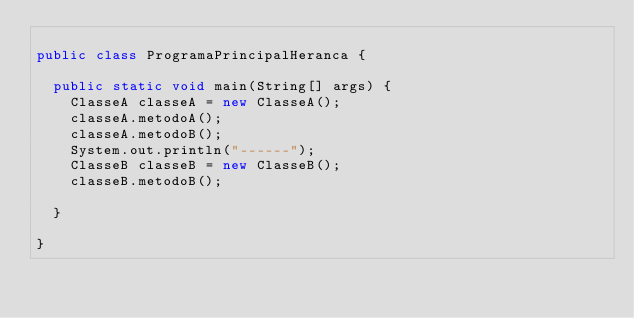<code> <loc_0><loc_0><loc_500><loc_500><_Java_>
public class ProgramaPrincipalHeranca {

	public static void main(String[] args) {
		ClasseA classeA = new ClasseA();
		classeA.metodoA();
		classeA.metodoB();
		System.out.println("------");
		ClasseB classeB = new ClasseB();
		classeB.metodoB();
		
	}

}
</code> 